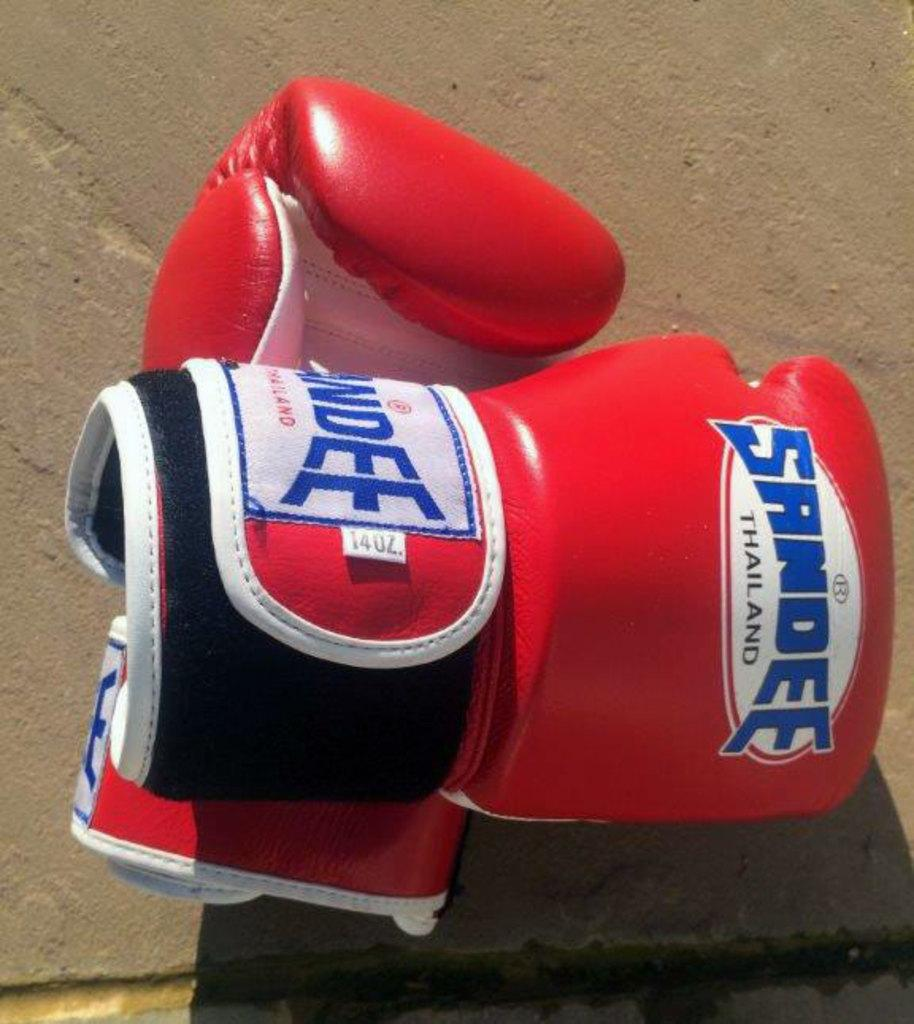Provide a one-sentence caption for the provided image. A pair of boxing gloves from Sandee Thailand sit on a concrete floor. 